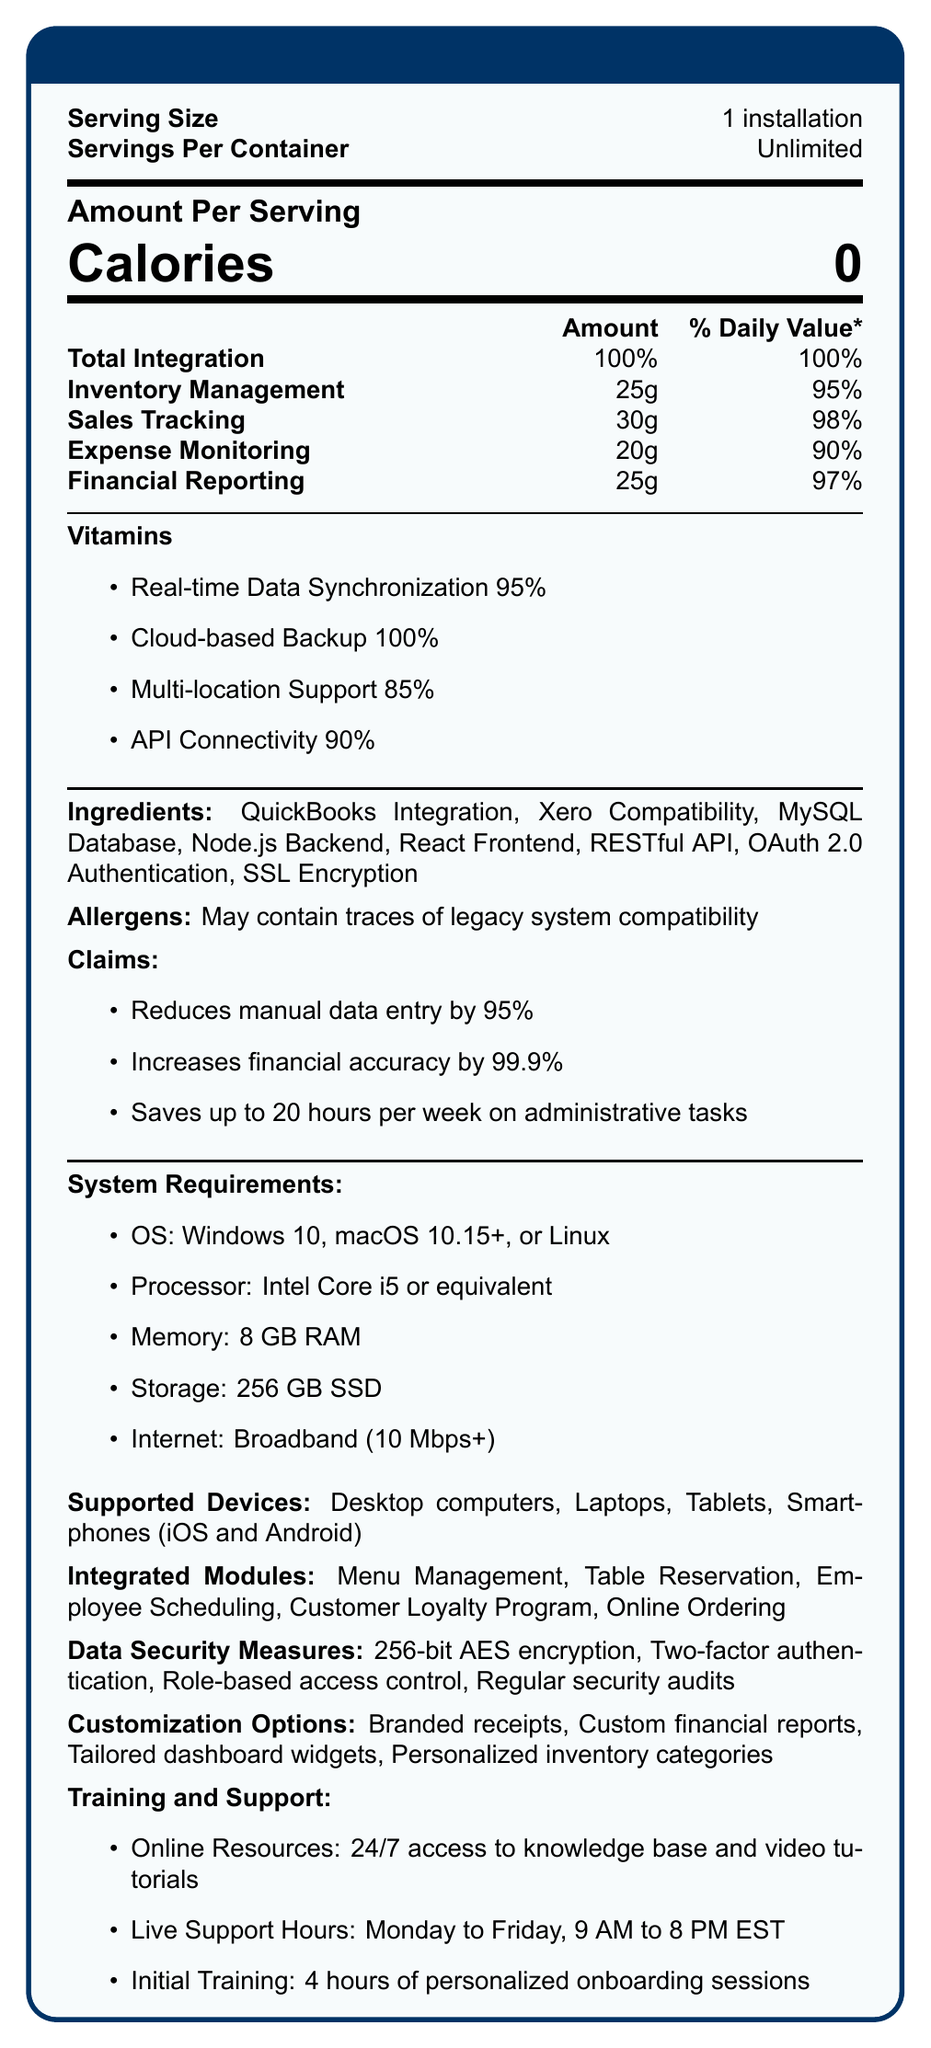What is the calorie content per serving of FineDine POS Pro? The document specifies that each serving has 0 calories.
Answer: 0 How many servings are there per container? The document states that the servings per container are unlimited.
Answer: Unlimited What is the daily value percentage of Inventory Management in FineDine POS Pro? The document indicates that Inventory Management has a daily value of 95%.
Answer: 95% Which ingredient is involved in enhancing the backend of FineDine POS Pro? The ingredients listed include Node.js Backend.
Answer: Node.js Backend List any two data security measures used by FineDine POS Pro. The data security measures mentioned include 256-bit AES encryption and Two-factor authentication.
Answer: 256-bit AES encryption, Two-factor authentication Which feature has the highest "daily value" percentage? A. Inventory Management B. Financial Reporting C. Sales Tracking D. Expense Monitoring Sales Tracking has a daily value of 98%, which is the highest among the listed features.
Answer: C. Sales Tracking Which of the following devices are supported by FineDine POS Pro? A. Smartwatches B. Laptops C. Projectors D. Desktop computers The supported devices mentioned are Desktop computers and Laptops.
Answer: B. Laptops and D. Desktop computers Is "Reduces manual data entry by 95%" a claim made by FineDine POS Pro? The document lists this as one of the claims.
Answer: Yes Summarize the main idea of the document. The nutrition facts-style document outlines the capabilities of the FineDine POS Pro system, emphasizing its integration with financial modules, system requirements, supported devices, data security measures, and customization options.
Answer: A detailed breakdown of FineDine POS Pro's features, system requirements, integration capabilities, and benefits. What percentage of the document are customization options? The document doesn't provide a percentage breakdown of customization options relative to the entire document.
Answer: Not enough information What is the amount of Financial Reporting per serving? The document indicates that Financial Reporting amounts to 25g per serving.
Answer: 25g What is the claim related to administrative tasks? One of the claims made by FineDine POS Pro is that it saves up to 20 hours per week on administrative tasks.
Answer: Saves up to 20 hours per week on administrative tasks Which advanced data synchronization feature does FineDine POS Pro provide? The document mentions Real-time Data Synchronization as a feature with 95% efficiency.
Answer: Real-time Data Synchronization What system requirements are crucial for FineDine POS Pro? The listed system requirements in the document include specific OS, processor, memory, storage, and internet connection requirements.
Answer: Windows 10, macOS 10.15+, or Linux; Intel Core i5 or equivalent; 8 GB RAM; 256 GB SSD; Broadband (10 Mbps+) Does FineDine POS Pro support legacy systems? The document mentions that it may contain traces of legacy system compatibility, indicating partial or potential support.
Answer: May contain traces of legacy system compatibility 